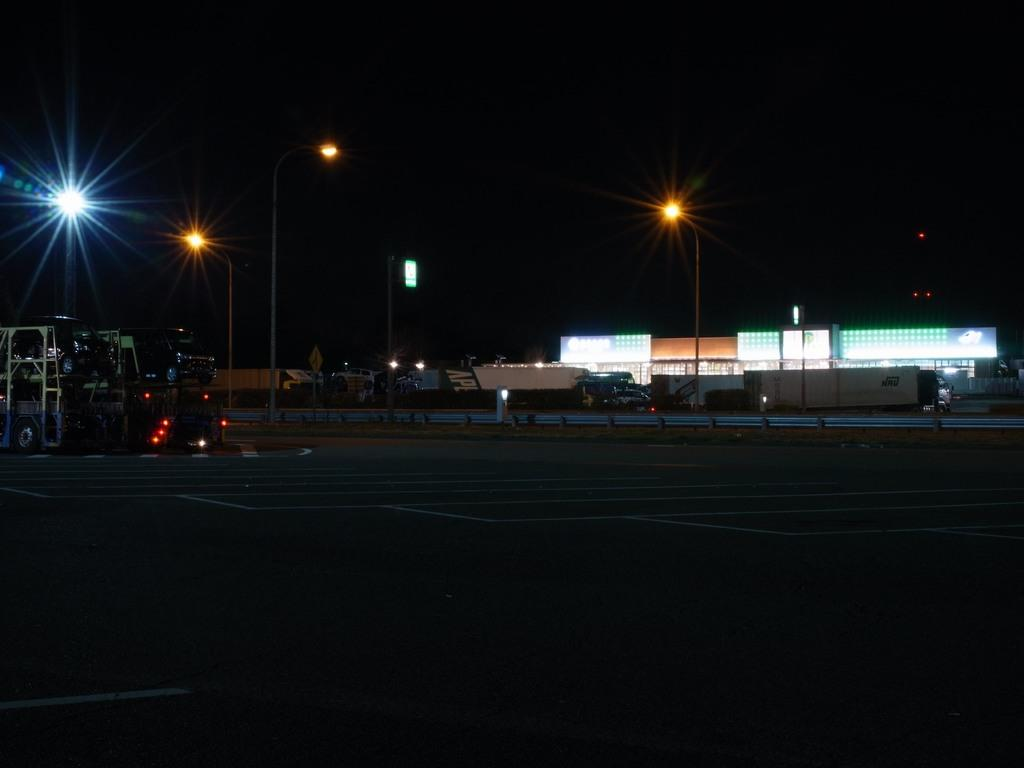What is the main feature of the image? There is a road in the image. What can be seen in the distance along the road? There are vehicles, buildings, poles, and sign boards in the background of the image. Can you describe the surroundings of the road? The surroundings include buildings, poles, and sign boards. What type of business is being conducted in the crib in the image? There is no crib present in the image, and therefore no business can be conducted in it. 